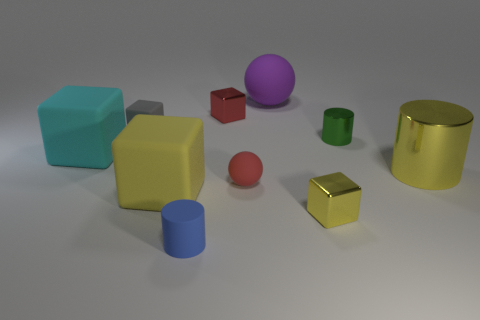There is a matte ball in front of the green thing; is it the same size as the tiny rubber cube?
Your response must be concise. Yes. What shape is the metallic object that is the same color as the small sphere?
Offer a terse response. Cube. What number of cubes are the same material as the tiny gray thing?
Make the answer very short. 2. What material is the block right of the tiny metallic cube to the left of the tiny cube on the right side of the large purple ball?
Offer a very short reply. Metal. The small matte object that is behind the tiny cylinder right of the red metallic object is what color?
Offer a terse response. Gray. What is the color of the cylinder that is the same size as the purple rubber sphere?
Make the answer very short. Yellow. How many tiny objects are either gray blocks or purple rubber spheres?
Give a very brief answer. 1. Is the number of tiny rubber cubes that are right of the tiny gray cube greater than the number of small red blocks in front of the yellow metal cube?
Give a very brief answer. No. What size is the rubber cube that is the same color as the large cylinder?
Give a very brief answer. Large. What number of other objects are the same size as the purple ball?
Make the answer very short. 3. 